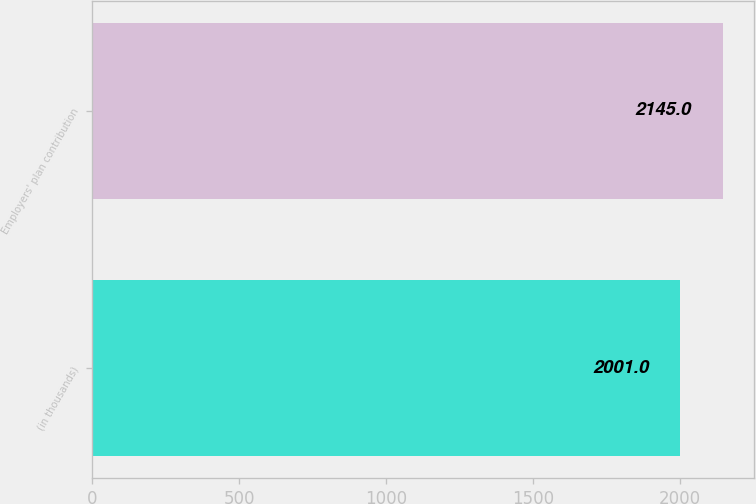Convert chart. <chart><loc_0><loc_0><loc_500><loc_500><bar_chart><fcel>(in thousands)<fcel>Employers' plan contribution<nl><fcel>2001<fcel>2145<nl></chart> 